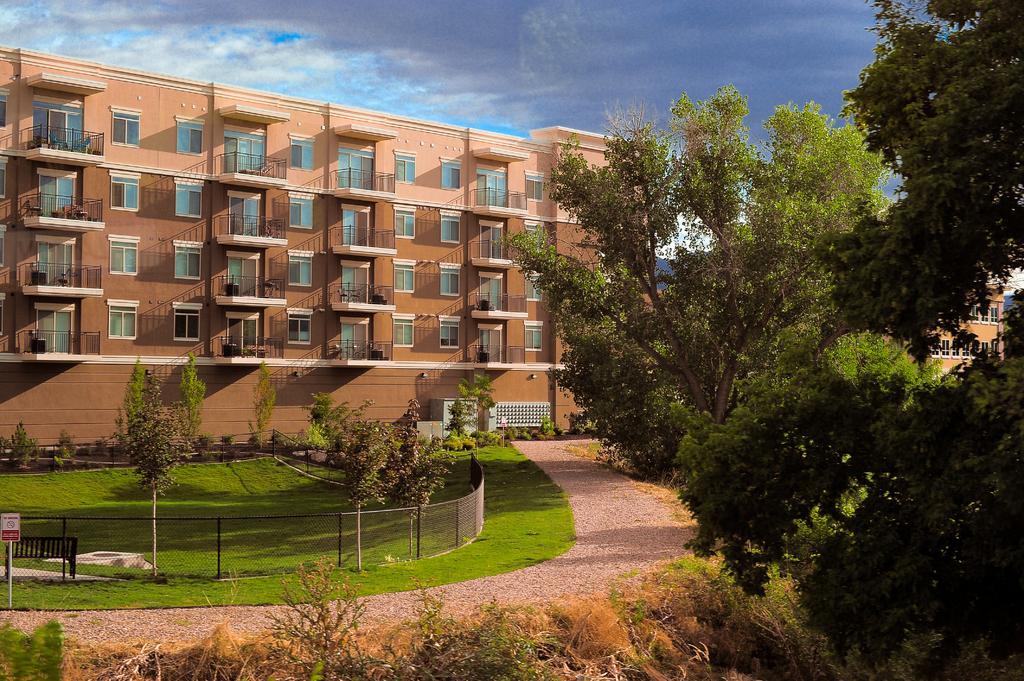Could you give a brief overview of what you see in this image? In this image I can see trees. There is a bench and a sign board on the left. There is a fence and grass. There is a building at the back. There are clouds in the sky. 